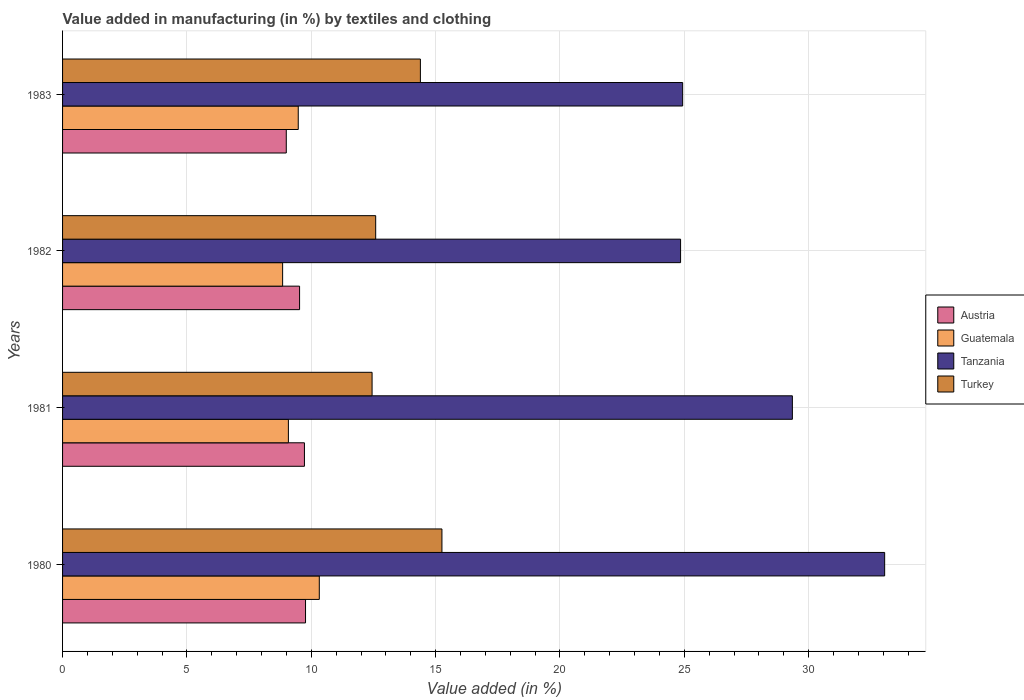Are the number of bars on each tick of the Y-axis equal?
Your answer should be compact. Yes. What is the label of the 3rd group of bars from the top?
Give a very brief answer. 1981. What is the percentage of value added in manufacturing by textiles and clothing in Guatemala in 1983?
Make the answer very short. 9.48. Across all years, what is the maximum percentage of value added in manufacturing by textiles and clothing in Guatemala?
Offer a terse response. 10.32. Across all years, what is the minimum percentage of value added in manufacturing by textiles and clothing in Tanzania?
Provide a short and direct response. 24.85. What is the total percentage of value added in manufacturing by textiles and clothing in Turkey in the graph?
Keep it short and to the point. 54.68. What is the difference between the percentage of value added in manufacturing by textiles and clothing in Guatemala in 1980 and that in 1982?
Provide a short and direct response. 1.47. What is the difference between the percentage of value added in manufacturing by textiles and clothing in Tanzania in 1980 and the percentage of value added in manufacturing by textiles and clothing in Turkey in 1982?
Provide a short and direct response. 20.47. What is the average percentage of value added in manufacturing by textiles and clothing in Tanzania per year?
Give a very brief answer. 28.05. In the year 1983, what is the difference between the percentage of value added in manufacturing by textiles and clothing in Austria and percentage of value added in manufacturing by textiles and clothing in Turkey?
Offer a very short reply. -5.39. What is the ratio of the percentage of value added in manufacturing by textiles and clothing in Turkey in 1982 to that in 1983?
Ensure brevity in your answer.  0.88. Is the percentage of value added in manufacturing by textiles and clothing in Guatemala in 1980 less than that in 1981?
Give a very brief answer. No. What is the difference between the highest and the second highest percentage of value added in manufacturing by textiles and clothing in Guatemala?
Your response must be concise. 0.85. What is the difference between the highest and the lowest percentage of value added in manufacturing by textiles and clothing in Guatemala?
Your answer should be very brief. 1.47. Is the sum of the percentage of value added in manufacturing by textiles and clothing in Austria in 1981 and 1983 greater than the maximum percentage of value added in manufacturing by textiles and clothing in Turkey across all years?
Keep it short and to the point. Yes. Is it the case that in every year, the sum of the percentage of value added in manufacturing by textiles and clothing in Guatemala and percentage of value added in manufacturing by textiles and clothing in Austria is greater than the sum of percentage of value added in manufacturing by textiles and clothing in Turkey and percentage of value added in manufacturing by textiles and clothing in Tanzania?
Provide a succinct answer. No. What does the 3rd bar from the top in 1980 represents?
Ensure brevity in your answer.  Guatemala. What does the 4th bar from the bottom in 1981 represents?
Your response must be concise. Turkey. Is it the case that in every year, the sum of the percentage of value added in manufacturing by textiles and clothing in Austria and percentage of value added in manufacturing by textiles and clothing in Tanzania is greater than the percentage of value added in manufacturing by textiles and clothing in Turkey?
Offer a terse response. Yes. How many bars are there?
Make the answer very short. 16. How many years are there in the graph?
Offer a very short reply. 4. Are the values on the major ticks of X-axis written in scientific E-notation?
Your response must be concise. No. Where does the legend appear in the graph?
Offer a terse response. Center right. How are the legend labels stacked?
Give a very brief answer. Vertical. What is the title of the graph?
Your response must be concise. Value added in manufacturing (in %) by textiles and clothing. Does "Palau" appear as one of the legend labels in the graph?
Provide a short and direct response. No. What is the label or title of the X-axis?
Ensure brevity in your answer.  Value added (in %). What is the label or title of the Y-axis?
Offer a very short reply. Years. What is the Value added (in %) of Austria in 1980?
Provide a succinct answer. 9.77. What is the Value added (in %) of Guatemala in 1980?
Provide a short and direct response. 10.32. What is the Value added (in %) in Tanzania in 1980?
Give a very brief answer. 33.06. What is the Value added (in %) in Turkey in 1980?
Offer a very short reply. 15.25. What is the Value added (in %) of Austria in 1981?
Your answer should be compact. 9.73. What is the Value added (in %) of Guatemala in 1981?
Provide a short and direct response. 9.08. What is the Value added (in %) of Tanzania in 1981?
Your answer should be very brief. 29.35. What is the Value added (in %) in Turkey in 1981?
Make the answer very short. 12.45. What is the Value added (in %) of Austria in 1982?
Your answer should be compact. 9.53. What is the Value added (in %) in Guatemala in 1982?
Give a very brief answer. 8.85. What is the Value added (in %) of Tanzania in 1982?
Offer a very short reply. 24.85. What is the Value added (in %) of Turkey in 1982?
Give a very brief answer. 12.59. What is the Value added (in %) of Austria in 1983?
Give a very brief answer. 9. What is the Value added (in %) of Guatemala in 1983?
Provide a succinct answer. 9.48. What is the Value added (in %) of Tanzania in 1983?
Give a very brief answer. 24.93. What is the Value added (in %) in Turkey in 1983?
Provide a short and direct response. 14.39. Across all years, what is the maximum Value added (in %) of Austria?
Provide a succinct answer. 9.77. Across all years, what is the maximum Value added (in %) in Guatemala?
Make the answer very short. 10.32. Across all years, what is the maximum Value added (in %) in Tanzania?
Make the answer very short. 33.06. Across all years, what is the maximum Value added (in %) of Turkey?
Provide a short and direct response. 15.25. Across all years, what is the minimum Value added (in %) in Austria?
Offer a terse response. 9. Across all years, what is the minimum Value added (in %) in Guatemala?
Ensure brevity in your answer.  8.85. Across all years, what is the minimum Value added (in %) in Tanzania?
Your response must be concise. 24.85. Across all years, what is the minimum Value added (in %) of Turkey?
Provide a succinct answer. 12.45. What is the total Value added (in %) in Austria in the graph?
Provide a succinct answer. 38.02. What is the total Value added (in %) in Guatemala in the graph?
Provide a succinct answer. 37.73. What is the total Value added (in %) of Tanzania in the graph?
Offer a terse response. 112.19. What is the total Value added (in %) in Turkey in the graph?
Keep it short and to the point. 54.68. What is the difference between the Value added (in %) of Austria in 1980 and that in 1981?
Keep it short and to the point. 0.04. What is the difference between the Value added (in %) of Guatemala in 1980 and that in 1981?
Make the answer very short. 1.24. What is the difference between the Value added (in %) in Tanzania in 1980 and that in 1981?
Your response must be concise. 3.71. What is the difference between the Value added (in %) in Turkey in 1980 and that in 1981?
Make the answer very short. 2.81. What is the difference between the Value added (in %) of Austria in 1980 and that in 1982?
Your answer should be compact. 0.24. What is the difference between the Value added (in %) in Guatemala in 1980 and that in 1982?
Provide a short and direct response. 1.47. What is the difference between the Value added (in %) of Tanzania in 1980 and that in 1982?
Provide a short and direct response. 8.21. What is the difference between the Value added (in %) of Turkey in 1980 and that in 1982?
Your response must be concise. 2.66. What is the difference between the Value added (in %) in Austria in 1980 and that in 1983?
Your answer should be very brief. 0.77. What is the difference between the Value added (in %) of Guatemala in 1980 and that in 1983?
Make the answer very short. 0.85. What is the difference between the Value added (in %) of Tanzania in 1980 and that in 1983?
Your answer should be compact. 8.12. What is the difference between the Value added (in %) in Turkey in 1980 and that in 1983?
Give a very brief answer. 0.87. What is the difference between the Value added (in %) in Austria in 1981 and that in 1982?
Your answer should be compact. 0.2. What is the difference between the Value added (in %) of Guatemala in 1981 and that in 1982?
Ensure brevity in your answer.  0.23. What is the difference between the Value added (in %) in Tanzania in 1981 and that in 1982?
Your answer should be very brief. 4.5. What is the difference between the Value added (in %) in Turkey in 1981 and that in 1982?
Offer a terse response. -0.14. What is the difference between the Value added (in %) of Austria in 1981 and that in 1983?
Offer a terse response. 0.73. What is the difference between the Value added (in %) of Guatemala in 1981 and that in 1983?
Make the answer very short. -0.4. What is the difference between the Value added (in %) in Tanzania in 1981 and that in 1983?
Your answer should be compact. 4.41. What is the difference between the Value added (in %) in Turkey in 1981 and that in 1983?
Provide a short and direct response. -1.94. What is the difference between the Value added (in %) of Austria in 1982 and that in 1983?
Ensure brevity in your answer.  0.53. What is the difference between the Value added (in %) of Guatemala in 1982 and that in 1983?
Provide a short and direct response. -0.63. What is the difference between the Value added (in %) in Tanzania in 1982 and that in 1983?
Your response must be concise. -0.08. What is the difference between the Value added (in %) in Turkey in 1982 and that in 1983?
Your answer should be very brief. -1.8. What is the difference between the Value added (in %) in Austria in 1980 and the Value added (in %) in Guatemala in 1981?
Ensure brevity in your answer.  0.69. What is the difference between the Value added (in %) of Austria in 1980 and the Value added (in %) of Tanzania in 1981?
Your answer should be very brief. -19.58. What is the difference between the Value added (in %) in Austria in 1980 and the Value added (in %) in Turkey in 1981?
Give a very brief answer. -2.68. What is the difference between the Value added (in %) in Guatemala in 1980 and the Value added (in %) in Tanzania in 1981?
Provide a succinct answer. -19.02. What is the difference between the Value added (in %) in Guatemala in 1980 and the Value added (in %) in Turkey in 1981?
Keep it short and to the point. -2.12. What is the difference between the Value added (in %) in Tanzania in 1980 and the Value added (in %) in Turkey in 1981?
Keep it short and to the point. 20.61. What is the difference between the Value added (in %) of Austria in 1980 and the Value added (in %) of Guatemala in 1982?
Your answer should be compact. 0.92. What is the difference between the Value added (in %) in Austria in 1980 and the Value added (in %) in Tanzania in 1982?
Offer a very short reply. -15.08. What is the difference between the Value added (in %) in Austria in 1980 and the Value added (in %) in Turkey in 1982?
Provide a short and direct response. -2.82. What is the difference between the Value added (in %) in Guatemala in 1980 and the Value added (in %) in Tanzania in 1982?
Provide a succinct answer. -14.53. What is the difference between the Value added (in %) of Guatemala in 1980 and the Value added (in %) of Turkey in 1982?
Ensure brevity in your answer.  -2.27. What is the difference between the Value added (in %) in Tanzania in 1980 and the Value added (in %) in Turkey in 1982?
Ensure brevity in your answer.  20.47. What is the difference between the Value added (in %) in Austria in 1980 and the Value added (in %) in Guatemala in 1983?
Provide a short and direct response. 0.29. What is the difference between the Value added (in %) in Austria in 1980 and the Value added (in %) in Tanzania in 1983?
Ensure brevity in your answer.  -15.16. What is the difference between the Value added (in %) of Austria in 1980 and the Value added (in %) of Turkey in 1983?
Ensure brevity in your answer.  -4.62. What is the difference between the Value added (in %) of Guatemala in 1980 and the Value added (in %) of Tanzania in 1983?
Make the answer very short. -14.61. What is the difference between the Value added (in %) of Guatemala in 1980 and the Value added (in %) of Turkey in 1983?
Give a very brief answer. -4.06. What is the difference between the Value added (in %) in Tanzania in 1980 and the Value added (in %) in Turkey in 1983?
Offer a terse response. 18.67. What is the difference between the Value added (in %) in Austria in 1981 and the Value added (in %) in Guatemala in 1982?
Your response must be concise. 0.88. What is the difference between the Value added (in %) in Austria in 1981 and the Value added (in %) in Tanzania in 1982?
Offer a terse response. -15.13. What is the difference between the Value added (in %) in Austria in 1981 and the Value added (in %) in Turkey in 1982?
Offer a terse response. -2.87. What is the difference between the Value added (in %) of Guatemala in 1981 and the Value added (in %) of Tanzania in 1982?
Give a very brief answer. -15.77. What is the difference between the Value added (in %) of Guatemala in 1981 and the Value added (in %) of Turkey in 1982?
Give a very brief answer. -3.51. What is the difference between the Value added (in %) of Tanzania in 1981 and the Value added (in %) of Turkey in 1982?
Offer a very short reply. 16.76. What is the difference between the Value added (in %) in Austria in 1981 and the Value added (in %) in Guatemala in 1983?
Ensure brevity in your answer.  0.25. What is the difference between the Value added (in %) in Austria in 1981 and the Value added (in %) in Tanzania in 1983?
Provide a short and direct response. -15.21. What is the difference between the Value added (in %) in Austria in 1981 and the Value added (in %) in Turkey in 1983?
Offer a terse response. -4.66. What is the difference between the Value added (in %) in Guatemala in 1981 and the Value added (in %) in Tanzania in 1983?
Make the answer very short. -15.85. What is the difference between the Value added (in %) of Guatemala in 1981 and the Value added (in %) of Turkey in 1983?
Your answer should be very brief. -5.31. What is the difference between the Value added (in %) in Tanzania in 1981 and the Value added (in %) in Turkey in 1983?
Ensure brevity in your answer.  14.96. What is the difference between the Value added (in %) of Austria in 1982 and the Value added (in %) of Guatemala in 1983?
Your answer should be compact. 0.05. What is the difference between the Value added (in %) of Austria in 1982 and the Value added (in %) of Tanzania in 1983?
Ensure brevity in your answer.  -15.4. What is the difference between the Value added (in %) in Austria in 1982 and the Value added (in %) in Turkey in 1983?
Provide a short and direct response. -4.86. What is the difference between the Value added (in %) in Guatemala in 1982 and the Value added (in %) in Tanzania in 1983?
Your answer should be very brief. -16.09. What is the difference between the Value added (in %) of Guatemala in 1982 and the Value added (in %) of Turkey in 1983?
Your answer should be very brief. -5.54. What is the difference between the Value added (in %) of Tanzania in 1982 and the Value added (in %) of Turkey in 1983?
Make the answer very short. 10.46. What is the average Value added (in %) in Austria per year?
Offer a terse response. 9.51. What is the average Value added (in %) in Guatemala per year?
Ensure brevity in your answer.  9.43. What is the average Value added (in %) in Tanzania per year?
Give a very brief answer. 28.05. What is the average Value added (in %) in Turkey per year?
Your response must be concise. 13.67. In the year 1980, what is the difference between the Value added (in %) in Austria and Value added (in %) in Guatemala?
Offer a terse response. -0.55. In the year 1980, what is the difference between the Value added (in %) of Austria and Value added (in %) of Tanzania?
Provide a short and direct response. -23.29. In the year 1980, what is the difference between the Value added (in %) in Austria and Value added (in %) in Turkey?
Provide a succinct answer. -5.49. In the year 1980, what is the difference between the Value added (in %) of Guatemala and Value added (in %) of Tanzania?
Your response must be concise. -22.73. In the year 1980, what is the difference between the Value added (in %) in Guatemala and Value added (in %) in Turkey?
Offer a very short reply. -4.93. In the year 1980, what is the difference between the Value added (in %) in Tanzania and Value added (in %) in Turkey?
Keep it short and to the point. 17.8. In the year 1981, what is the difference between the Value added (in %) in Austria and Value added (in %) in Guatemala?
Provide a succinct answer. 0.64. In the year 1981, what is the difference between the Value added (in %) of Austria and Value added (in %) of Tanzania?
Give a very brief answer. -19.62. In the year 1981, what is the difference between the Value added (in %) in Austria and Value added (in %) in Turkey?
Provide a short and direct response. -2.72. In the year 1981, what is the difference between the Value added (in %) of Guatemala and Value added (in %) of Tanzania?
Keep it short and to the point. -20.27. In the year 1981, what is the difference between the Value added (in %) in Guatemala and Value added (in %) in Turkey?
Provide a short and direct response. -3.37. In the year 1981, what is the difference between the Value added (in %) of Tanzania and Value added (in %) of Turkey?
Ensure brevity in your answer.  16.9. In the year 1982, what is the difference between the Value added (in %) in Austria and Value added (in %) in Guatemala?
Provide a succinct answer. 0.68. In the year 1982, what is the difference between the Value added (in %) of Austria and Value added (in %) of Tanzania?
Provide a succinct answer. -15.32. In the year 1982, what is the difference between the Value added (in %) in Austria and Value added (in %) in Turkey?
Your response must be concise. -3.06. In the year 1982, what is the difference between the Value added (in %) in Guatemala and Value added (in %) in Tanzania?
Provide a short and direct response. -16. In the year 1982, what is the difference between the Value added (in %) in Guatemala and Value added (in %) in Turkey?
Ensure brevity in your answer.  -3.74. In the year 1982, what is the difference between the Value added (in %) in Tanzania and Value added (in %) in Turkey?
Give a very brief answer. 12.26. In the year 1983, what is the difference between the Value added (in %) in Austria and Value added (in %) in Guatemala?
Offer a terse response. -0.48. In the year 1983, what is the difference between the Value added (in %) in Austria and Value added (in %) in Tanzania?
Offer a very short reply. -15.94. In the year 1983, what is the difference between the Value added (in %) of Austria and Value added (in %) of Turkey?
Offer a very short reply. -5.39. In the year 1983, what is the difference between the Value added (in %) of Guatemala and Value added (in %) of Tanzania?
Offer a terse response. -15.46. In the year 1983, what is the difference between the Value added (in %) of Guatemala and Value added (in %) of Turkey?
Keep it short and to the point. -4.91. In the year 1983, what is the difference between the Value added (in %) of Tanzania and Value added (in %) of Turkey?
Ensure brevity in your answer.  10.55. What is the ratio of the Value added (in %) of Guatemala in 1980 to that in 1981?
Provide a succinct answer. 1.14. What is the ratio of the Value added (in %) in Tanzania in 1980 to that in 1981?
Ensure brevity in your answer.  1.13. What is the ratio of the Value added (in %) in Turkey in 1980 to that in 1981?
Ensure brevity in your answer.  1.23. What is the ratio of the Value added (in %) of Austria in 1980 to that in 1982?
Your answer should be compact. 1.03. What is the ratio of the Value added (in %) of Guatemala in 1980 to that in 1982?
Your response must be concise. 1.17. What is the ratio of the Value added (in %) of Tanzania in 1980 to that in 1982?
Ensure brevity in your answer.  1.33. What is the ratio of the Value added (in %) in Turkey in 1980 to that in 1982?
Your response must be concise. 1.21. What is the ratio of the Value added (in %) in Austria in 1980 to that in 1983?
Ensure brevity in your answer.  1.09. What is the ratio of the Value added (in %) of Guatemala in 1980 to that in 1983?
Offer a terse response. 1.09. What is the ratio of the Value added (in %) in Tanzania in 1980 to that in 1983?
Provide a short and direct response. 1.33. What is the ratio of the Value added (in %) of Turkey in 1980 to that in 1983?
Provide a succinct answer. 1.06. What is the ratio of the Value added (in %) of Austria in 1981 to that in 1982?
Your answer should be compact. 1.02. What is the ratio of the Value added (in %) in Guatemala in 1981 to that in 1982?
Offer a terse response. 1.03. What is the ratio of the Value added (in %) of Tanzania in 1981 to that in 1982?
Provide a short and direct response. 1.18. What is the ratio of the Value added (in %) in Austria in 1981 to that in 1983?
Offer a terse response. 1.08. What is the ratio of the Value added (in %) of Guatemala in 1981 to that in 1983?
Give a very brief answer. 0.96. What is the ratio of the Value added (in %) in Tanzania in 1981 to that in 1983?
Offer a very short reply. 1.18. What is the ratio of the Value added (in %) in Turkey in 1981 to that in 1983?
Provide a succinct answer. 0.86. What is the ratio of the Value added (in %) of Austria in 1982 to that in 1983?
Make the answer very short. 1.06. What is the ratio of the Value added (in %) of Guatemala in 1982 to that in 1983?
Offer a very short reply. 0.93. What is the ratio of the Value added (in %) in Turkey in 1982 to that in 1983?
Give a very brief answer. 0.88. What is the difference between the highest and the second highest Value added (in %) in Austria?
Your answer should be very brief. 0.04. What is the difference between the highest and the second highest Value added (in %) of Guatemala?
Your response must be concise. 0.85. What is the difference between the highest and the second highest Value added (in %) in Tanzania?
Ensure brevity in your answer.  3.71. What is the difference between the highest and the second highest Value added (in %) in Turkey?
Your answer should be compact. 0.87. What is the difference between the highest and the lowest Value added (in %) of Austria?
Provide a short and direct response. 0.77. What is the difference between the highest and the lowest Value added (in %) in Guatemala?
Your answer should be compact. 1.47. What is the difference between the highest and the lowest Value added (in %) in Tanzania?
Your answer should be very brief. 8.21. What is the difference between the highest and the lowest Value added (in %) in Turkey?
Provide a succinct answer. 2.81. 